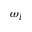<formula> <loc_0><loc_0><loc_500><loc_500>\omega _ { l }</formula> 